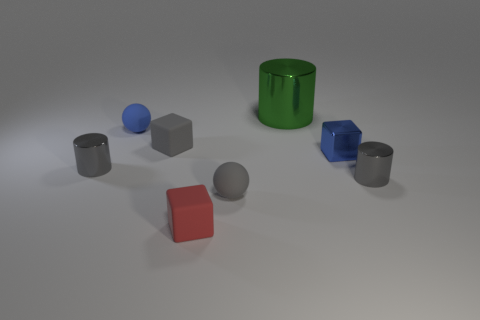Is there anything else that has the same size as the green metal thing?
Ensure brevity in your answer.  No. There is a small matte sphere that is behind the tiny gray matte block right of the metal cylinder left of the small gray rubber block; what is its color?
Offer a very short reply. Blue. Are there an equal number of balls in front of the small gray cube and tiny blue objects in front of the large metallic cylinder?
Ensure brevity in your answer.  No. There is a red object that is the same size as the blue matte thing; what is its shape?
Offer a very short reply. Cube. Are there any big matte cubes that have the same color as the big object?
Your response must be concise. No. There is a tiny gray rubber thing to the right of the tiny gray rubber block; what is its shape?
Your answer should be compact. Sphere. The large cylinder is what color?
Provide a short and direct response. Green. What color is the tiny cube that is the same material as the red thing?
Ensure brevity in your answer.  Gray. What number of gray things are made of the same material as the green cylinder?
Make the answer very short. 2. There is a red matte thing; what number of small metallic blocks are left of it?
Keep it short and to the point. 0. 